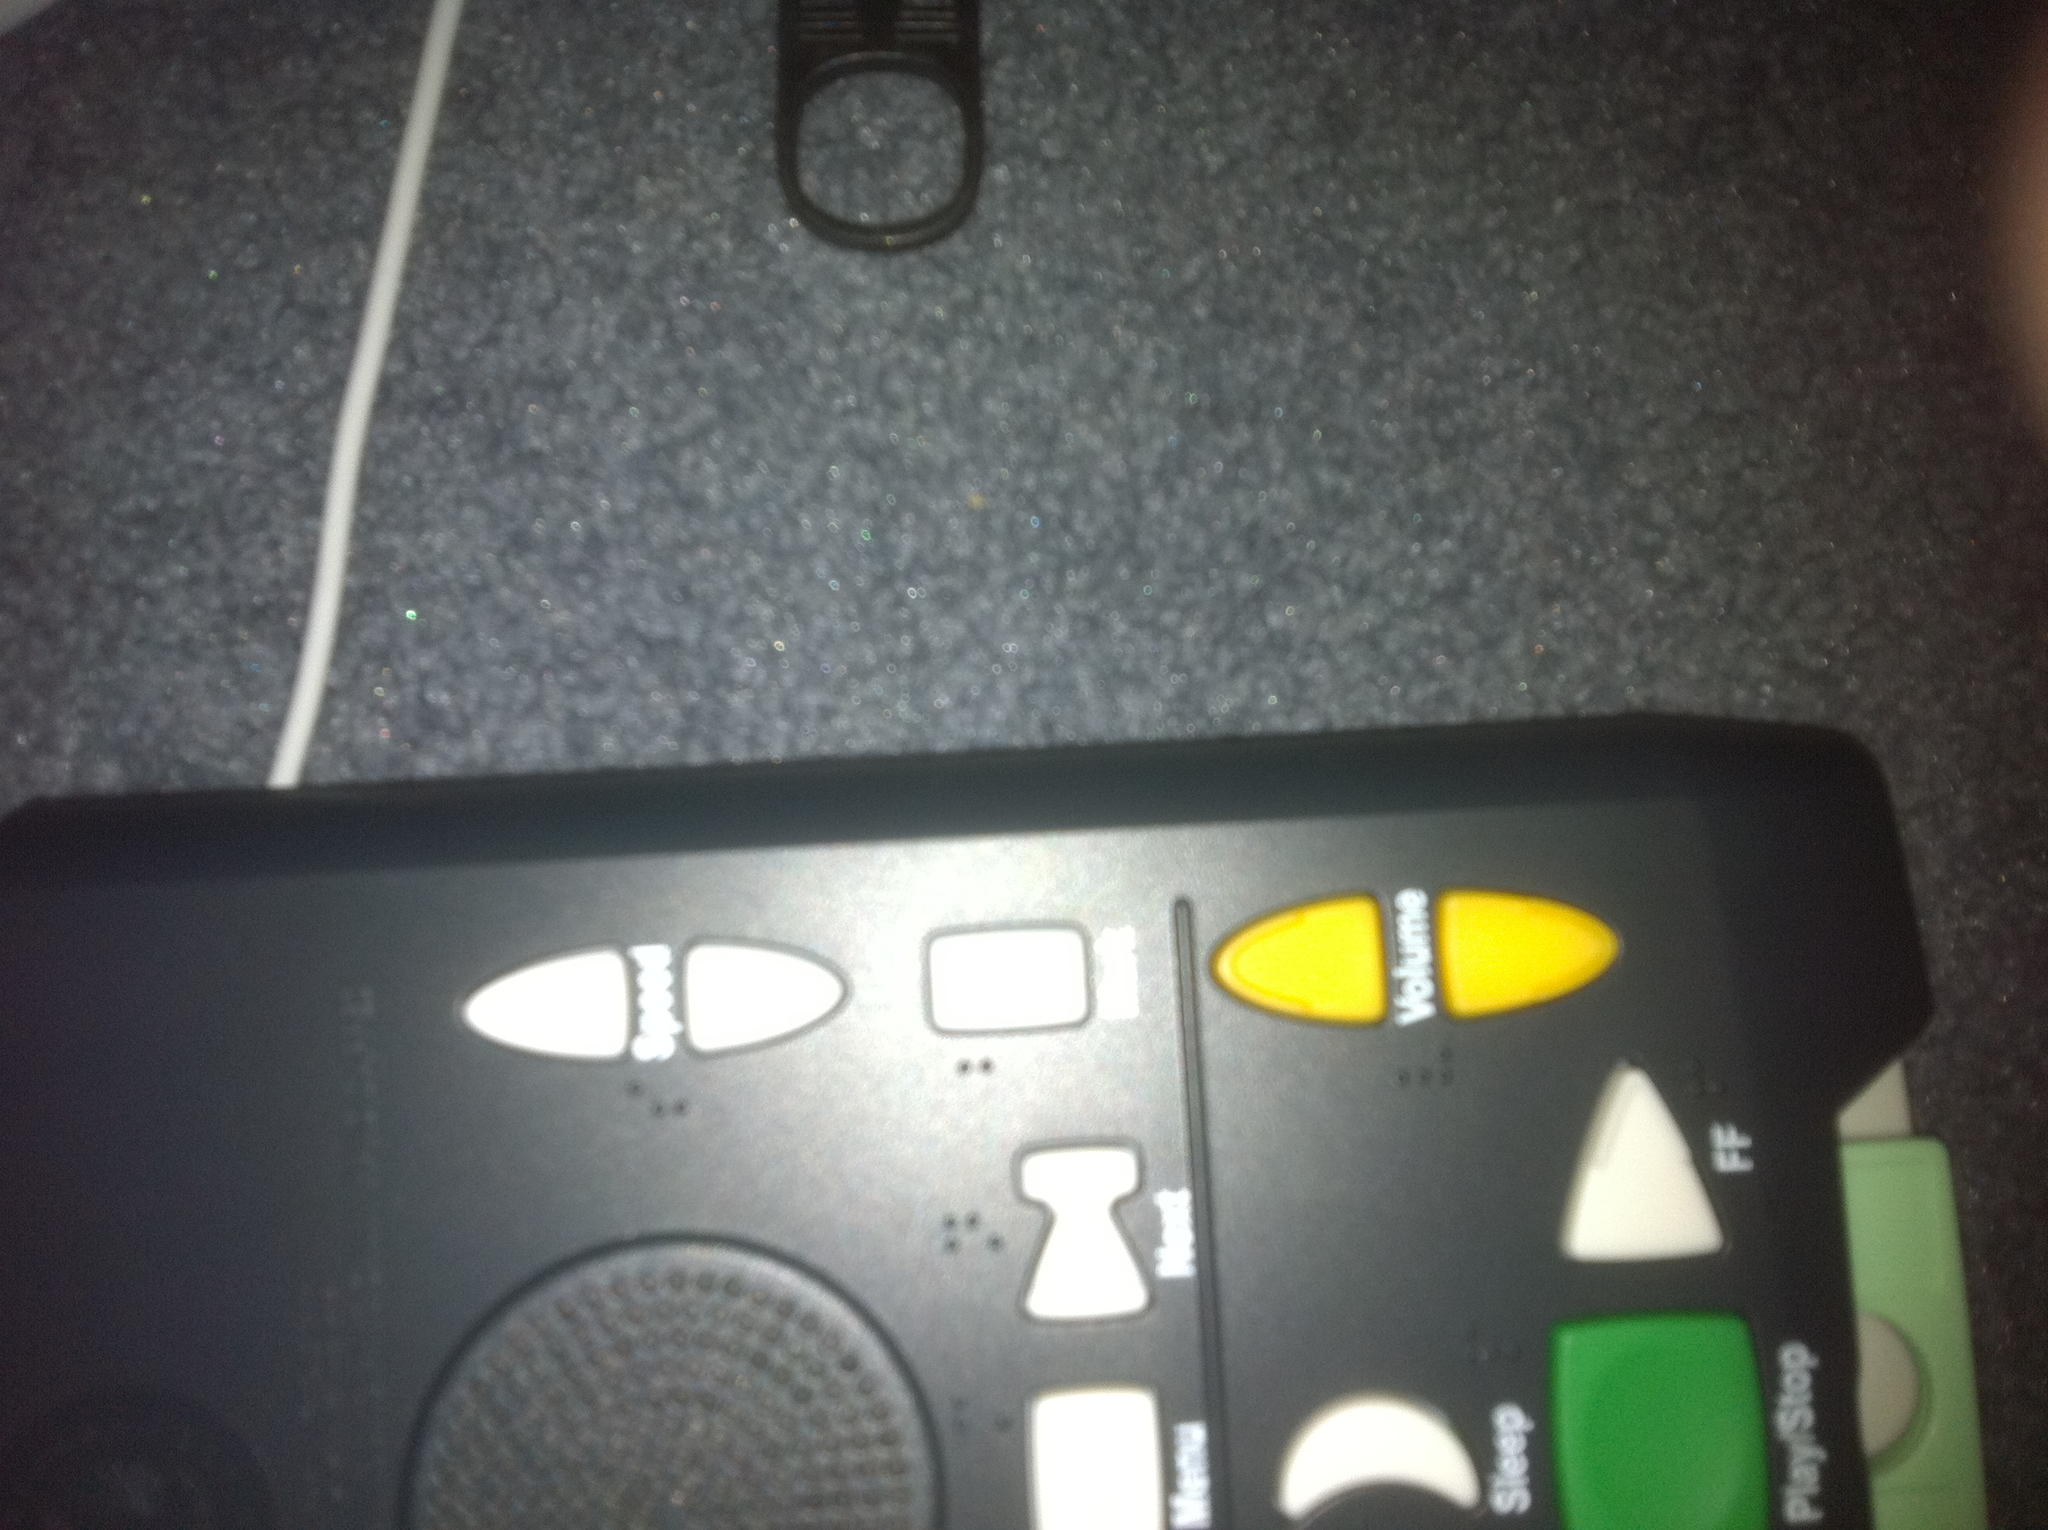How user-friendly do you think this remote control is based on the layout of the buttons? The remote control seems moderately user-friendly. The buttons are large and distinctly colored (white and yellow), which enhances visibility and ease of use. However, the labels might be small for some users, and the black background could make it hard to see in low light. 